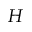Convert formula to latex. <formula><loc_0><loc_0><loc_500><loc_500>H</formula> 